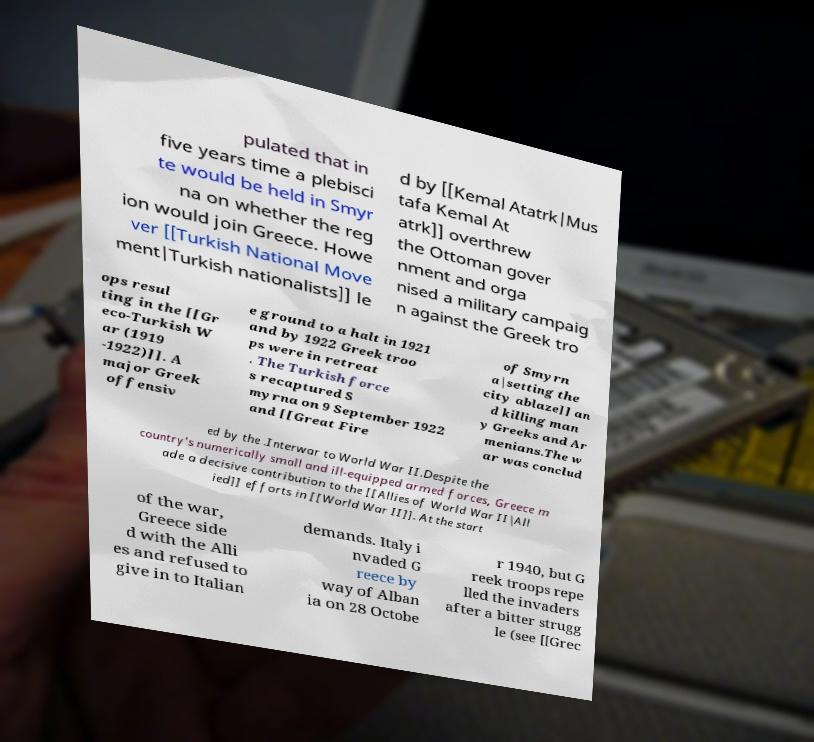Can you accurately transcribe the text from the provided image for me? pulated that in five years time a plebisci te would be held in Smyr na on whether the reg ion would join Greece. Howe ver [[Turkish National Move ment|Turkish nationalists]] le d by [[Kemal Atatrk|Mus tafa Kemal At atrk]] overthrew the Ottoman gover nment and orga nised a military campaig n against the Greek tro ops resul ting in the [[Gr eco-Turkish W ar (1919 -1922)]]. A major Greek offensiv e ground to a halt in 1921 and by 1922 Greek troo ps were in retreat . The Turkish force s recaptured S myrna on 9 September 1922 and [[Great Fire of Smyrn a|setting the city ablaze]] an d killing man y Greeks and Ar menians.The w ar was conclud ed by the .Interwar to World War II.Despite the country's numerically small and ill-equipped armed forces, Greece m ade a decisive contribution to the [[Allies of World War II|All ied]] efforts in [[World War II]]. At the start of the war, Greece side d with the Alli es and refused to give in to Italian demands. Italy i nvaded G reece by way of Alban ia on 28 Octobe r 1940, but G reek troops repe lled the invaders after a bitter strugg le (see [[Grec 